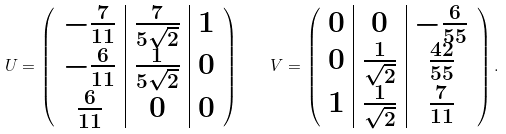<formula> <loc_0><loc_0><loc_500><loc_500>U = \left ( \begin{array} { c | c | c } - \frac { 7 } { 1 1 } & \frac { 7 } { 5 \sqrt { 2 } } & 1 \\ - \frac { 6 } { 1 1 } & \frac { 1 } { 5 \sqrt { 2 } } & 0 \\ \frac { 6 } { 1 1 } & 0 & 0 \end{array} \right ) \quad V = \left ( \begin{array} { c | c | c } 0 & 0 & - \frac { 6 } { 5 5 } \\ 0 & \frac { 1 } { \sqrt { 2 } } & \frac { 4 2 } { 5 5 } \\ 1 & \frac { 1 } { \sqrt { 2 } } & \frac { 7 } { 1 1 } \end{array} \right ) .</formula> 